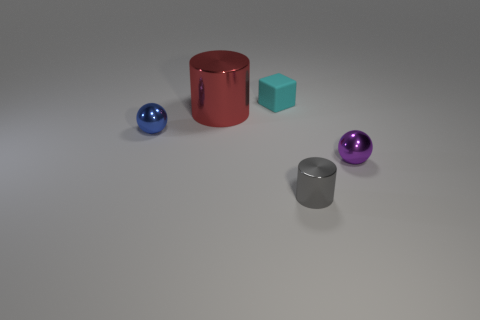Is there anything else that is the same size as the red object?
Offer a terse response. No. Is the color of the matte cube the same as the large cylinder?
Your answer should be very brief. No. How many small rubber blocks are the same color as the small metal cylinder?
Keep it short and to the point. 0. Are there more small cyan matte blocks than tiny metal spheres?
Give a very brief answer. No. What size is the metallic object that is both on the left side of the tiny cube and on the right side of the tiny blue object?
Offer a terse response. Large. Is the ball behind the small purple metallic object made of the same material as the ball that is on the right side of the large cylinder?
Provide a short and direct response. Yes. What is the shape of the other purple object that is the same size as the matte object?
Your answer should be very brief. Sphere. Is the number of blue balls less than the number of large blue things?
Give a very brief answer. No. There is a tiny ball that is on the right side of the small metallic cylinder; are there any small metallic objects in front of it?
Offer a very short reply. Yes. There is a tiny sphere that is to the right of the metallic object in front of the purple metal thing; is there a small cyan matte cube on the right side of it?
Ensure brevity in your answer.  No. 